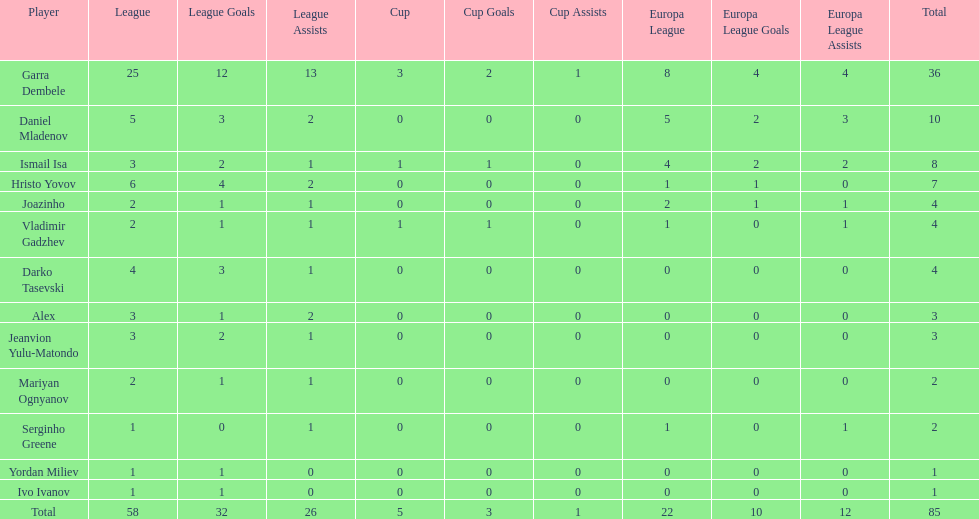How many players had a total of 4? 3. 